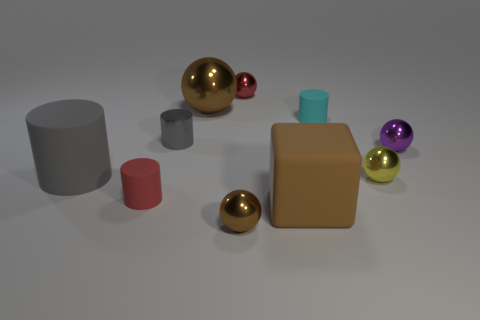Subtract all large spheres. How many spheres are left? 4 Subtract all red balls. How many balls are left? 4 Subtract all green spheres. Subtract all blue cylinders. How many spheres are left? 5 Subtract all cubes. How many objects are left? 9 Add 1 big green matte objects. How many big green matte objects exist? 1 Subtract 0 blue cylinders. How many objects are left? 10 Subtract all big gray objects. Subtract all cyan cylinders. How many objects are left? 8 Add 7 big brown spheres. How many big brown spheres are left? 8 